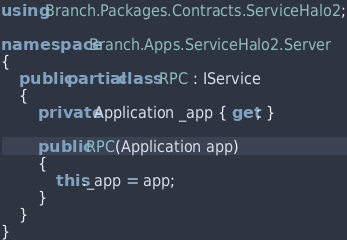<code> <loc_0><loc_0><loc_500><loc_500><_C#_>using Branch.Packages.Contracts.ServiceHalo2;

namespace Branch.Apps.ServiceHalo2.Server
{
	public partial class RPC : IService
	{
		private Application _app { get; }

		public RPC(Application app)
		{
			this._app = app;
		}
	}
}
</code> 